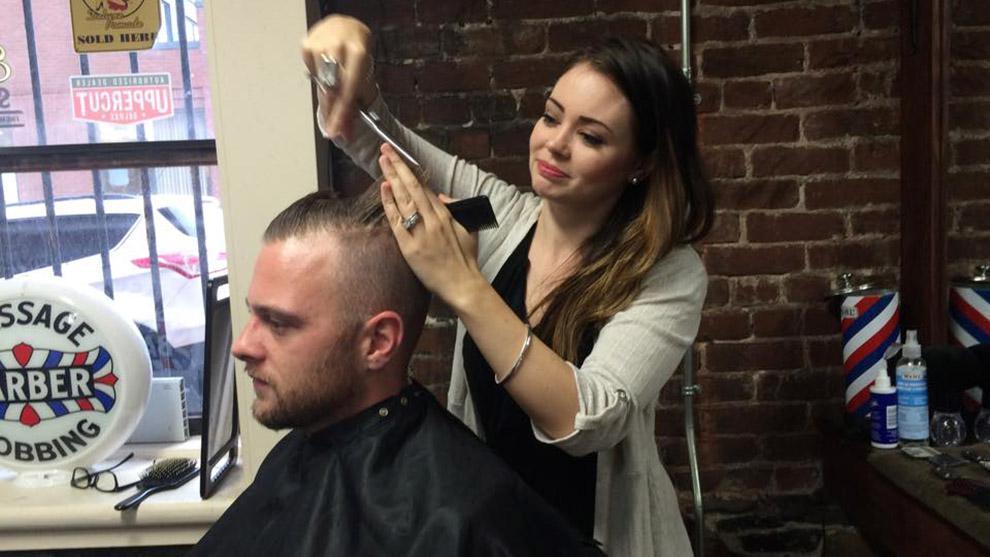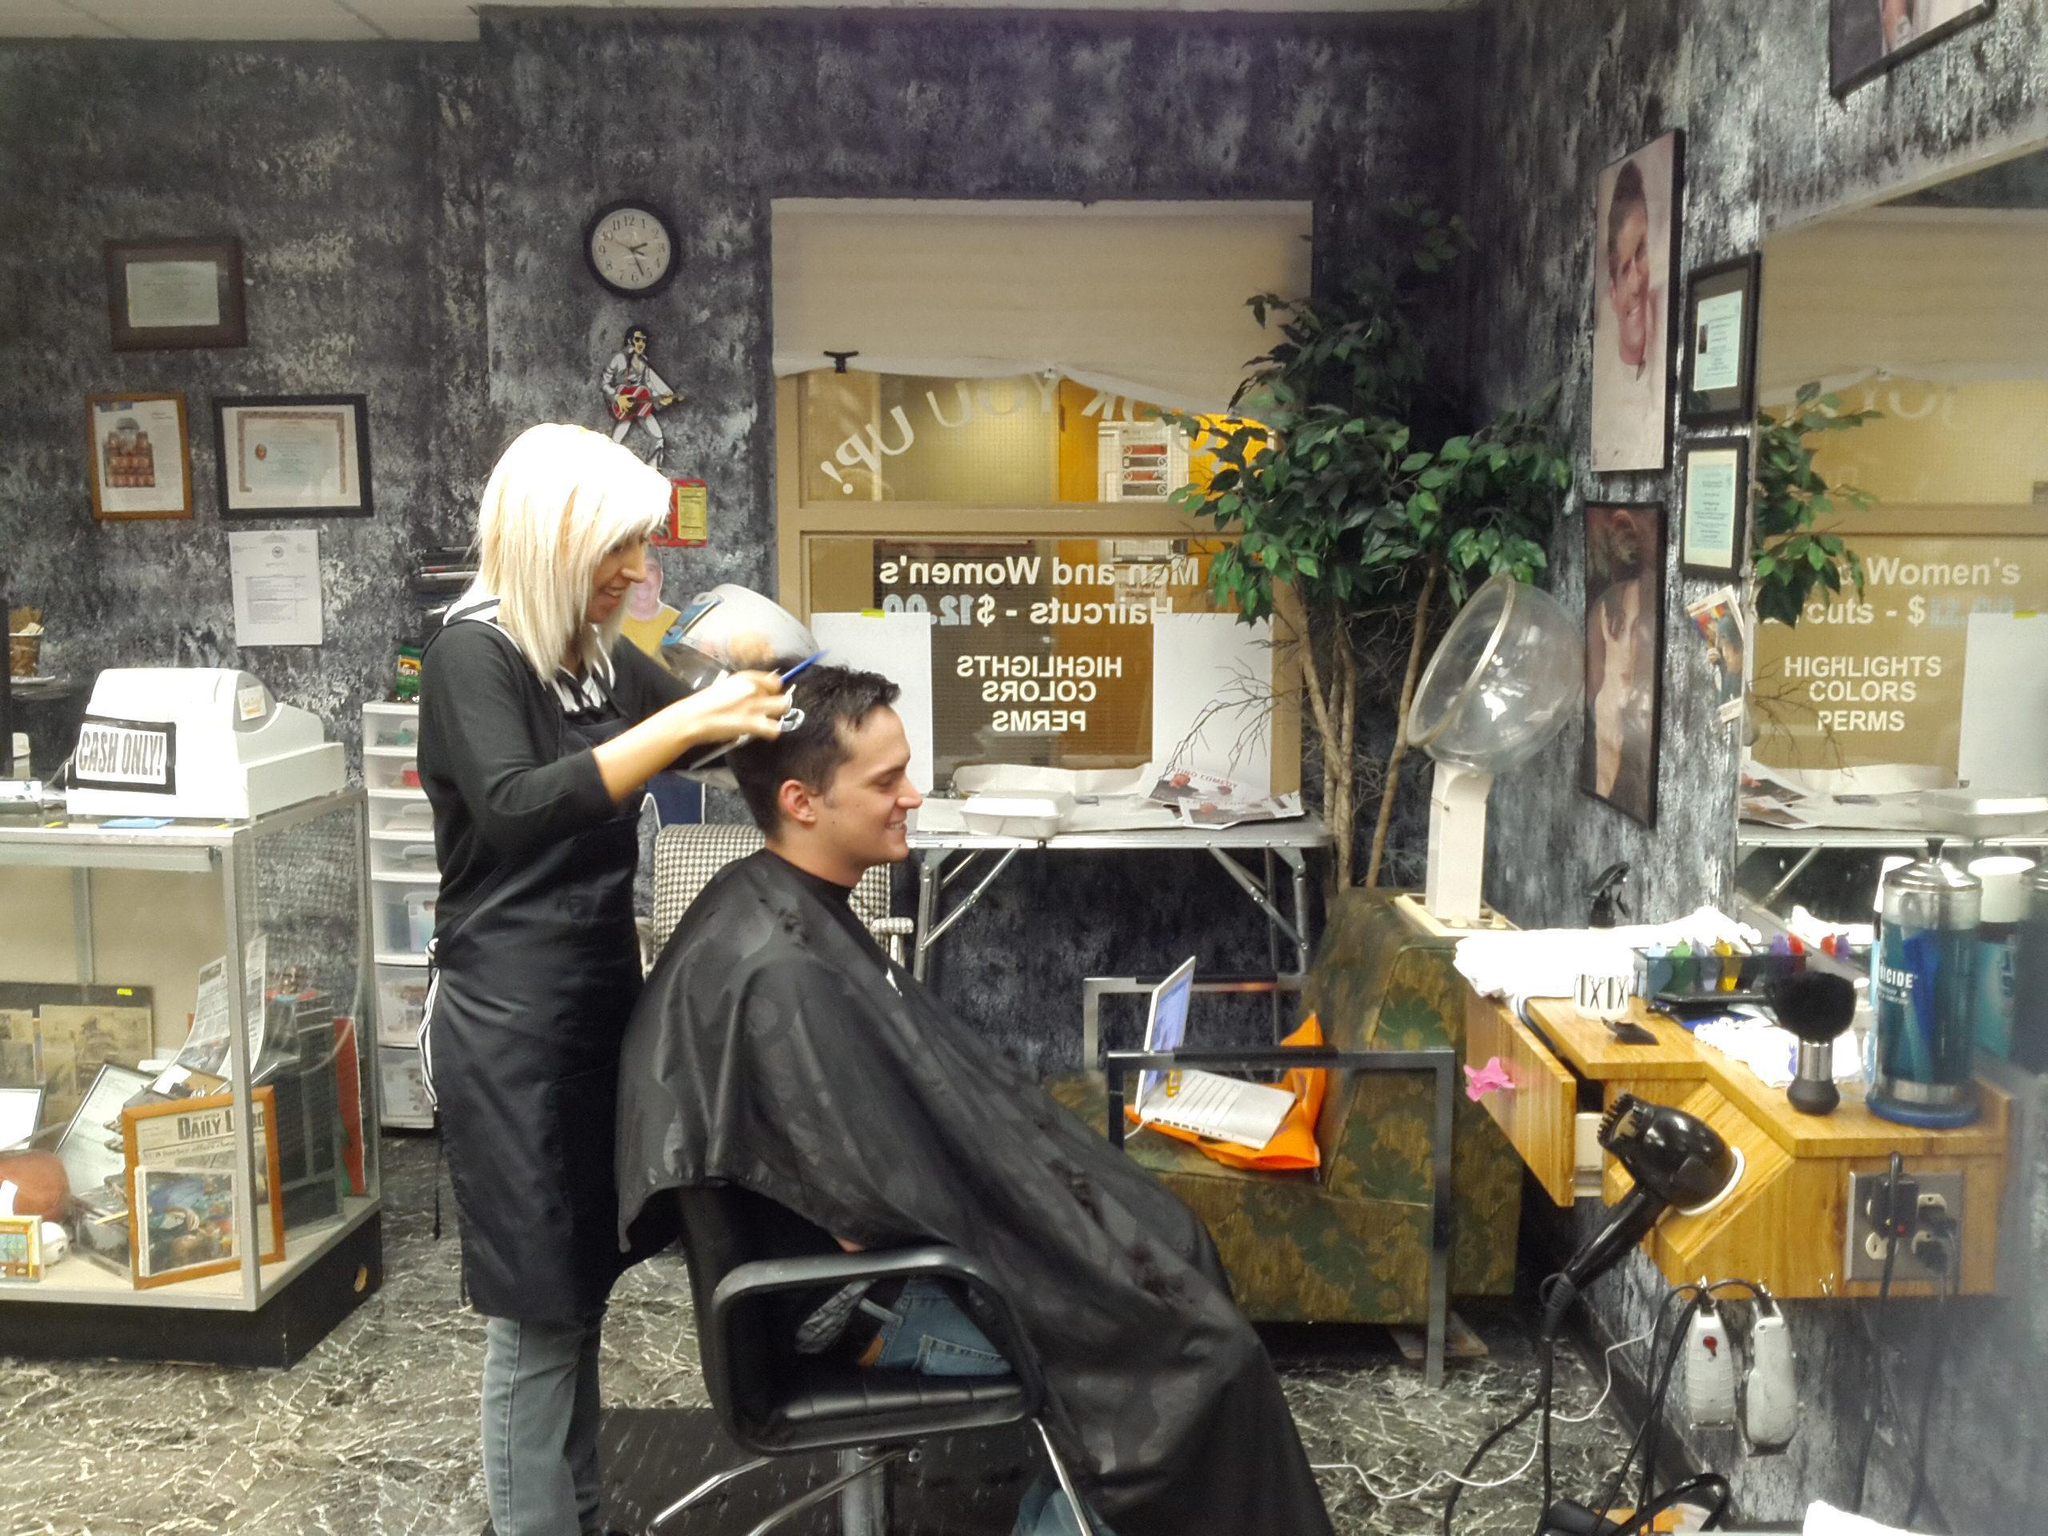The first image is the image on the left, the second image is the image on the right. Assess this claim about the two images: "An image shows salon customers wearing purple protective capes.". Correct or not? Answer yes or no. No. The first image is the image on the left, the second image is the image on the right. Examine the images to the left and right. Is the description "At least one of the images has someone getting their hair cut with a purple apron over their laps." accurate? Answer yes or no. No. 